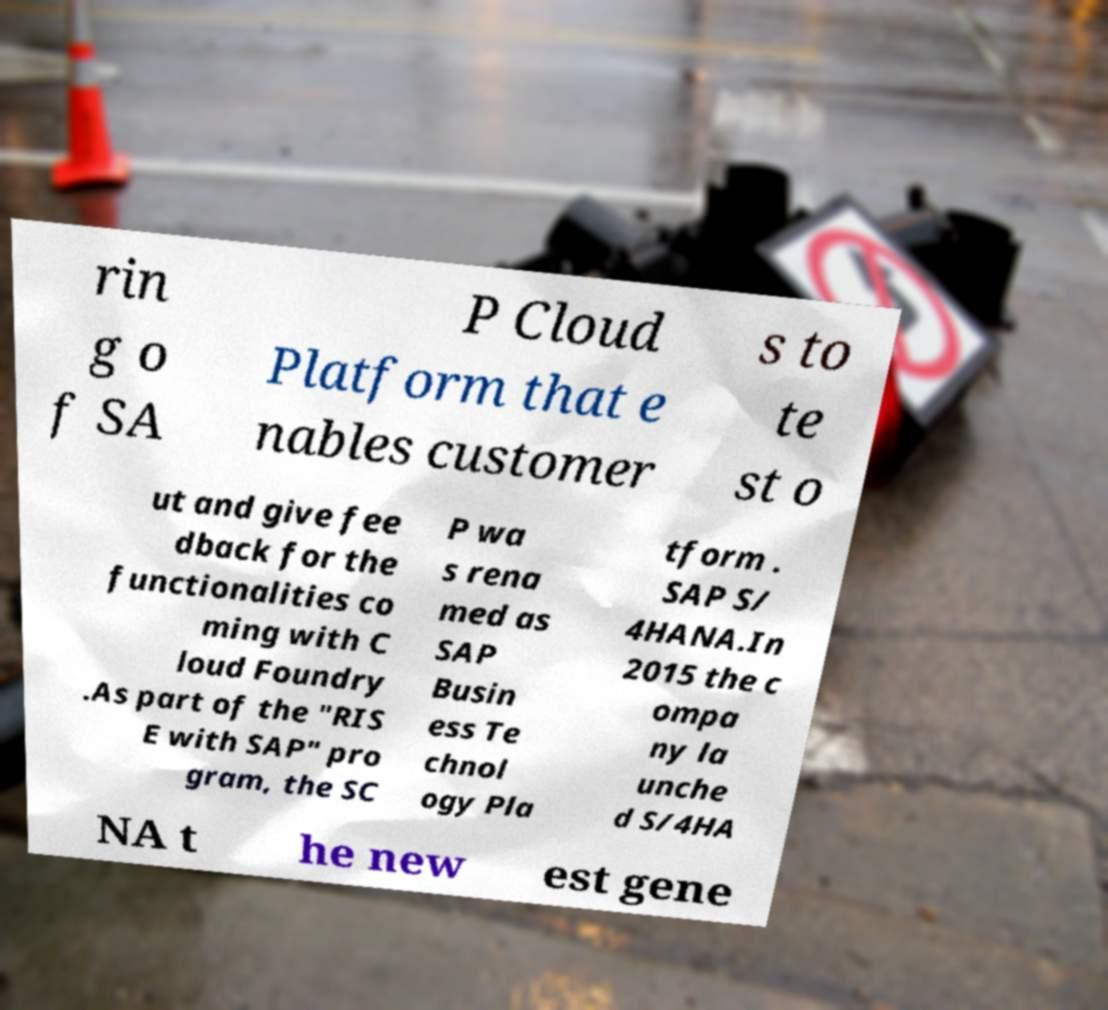What messages or text are displayed in this image? I need them in a readable, typed format. rin g o f SA P Cloud Platform that e nables customer s to te st o ut and give fee dback for the functionalities co ming with C loud Foundry .As part of the "RIS E with SAP" pro gram, the SC P wa s rena med as SAP Busin ess Te chnol ogy Pla tform . SAP S/ 4HANA.In 2015 the c ompa ny la unche d S/4HA NA t he new est gene 